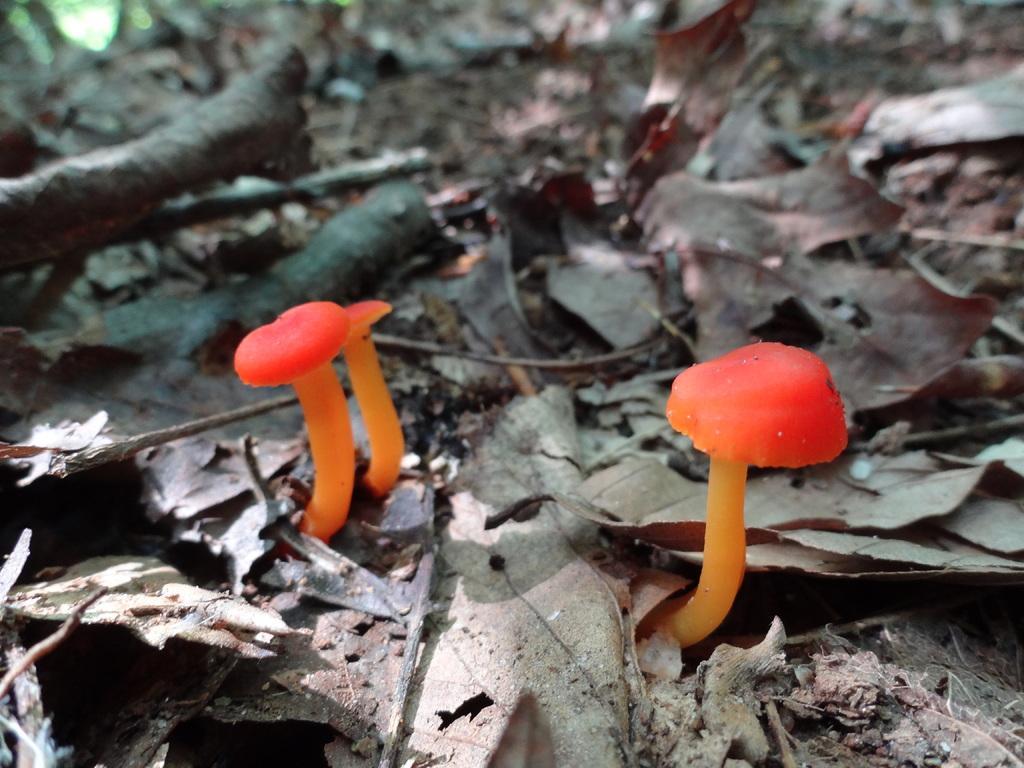How would you summarize this image in a sentence or two? In this image there are two mushrooms on the surface of dry leaves. 